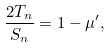Convert formula to latex. <formula><loc_0><loc_0><loc_500><loc_500>\frac { 2 T _ { n } } { S _ { n } } = 1 - \mu ^ { \prime } ,</formula> 